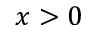<formula> <loc_0><loc_0><loc_500><loc_500>x > 0</formula> 